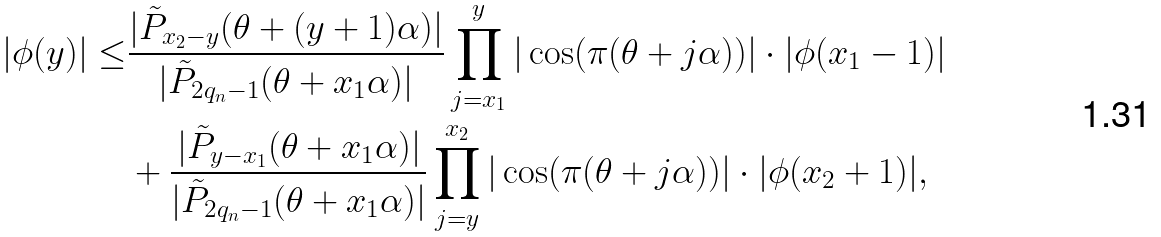<formula> <loc_0><loc_0><loc_500><loc_500>| \phi ( y ) | \leq & \frac { | \tilde { P } _ { x _ { 2 } - y } ( \theta + ( y + 1 ) \alpha ) | } { | \tilde { P } _ { 2 q _ { n } - 1 } ( \theta + x _ { 1 } \alpha ) | } \prod _ { j = x _ { 1 } } ^ { y } | \cos ( \pi ( \theta + j \alpha ) ) | \cdot | \phi ( x _ { 1 } - 1 ) | \\ & + \frac { | \tilde { P } _ { y - x _ { 1 } } ( \theta + x _ { 1 } \alpha ) | } { | \tilde { P } _ { 2 q _ { n } - 1 } ( \theta + x _ { 1 } \alpha ) | } \prod _ { j = y } ^ { x _ { 2 } } | \cos ( \pi ( \theta + j \alpha ) ) | \cdot | \phi ( x _ { 2 } + 1 ) | ,</formula> 